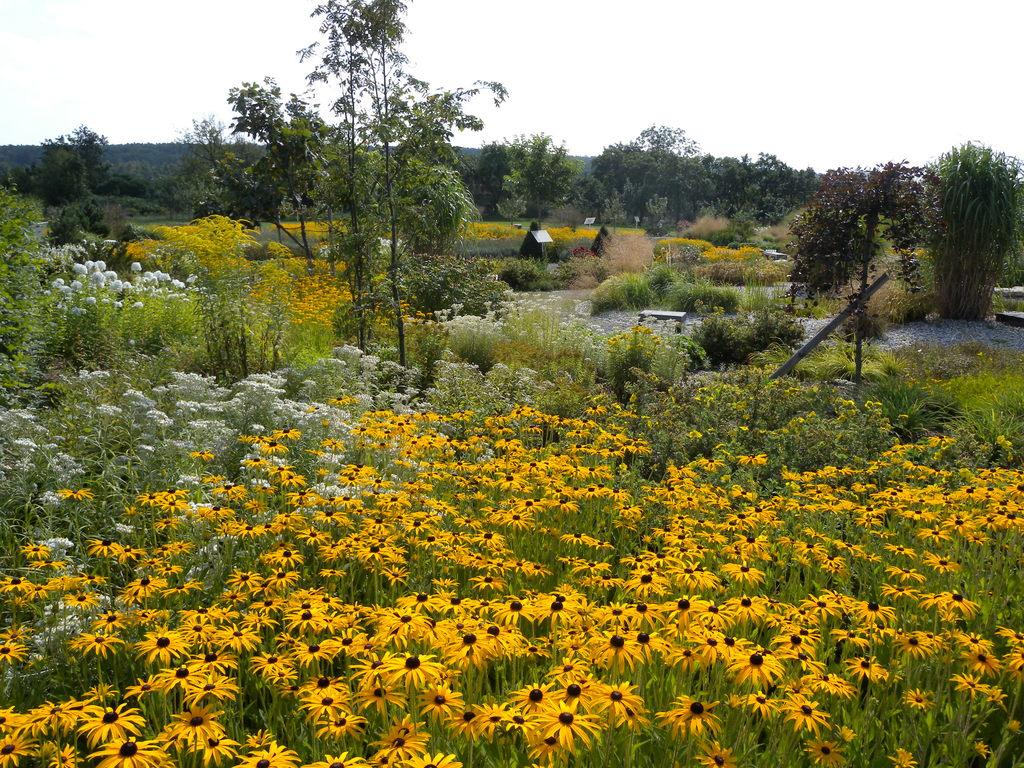What type of landscape is depicted at the bottom side of the image? There is a flower field at the bottom side of the image. What can be seen in the background area of the image? There are boards and trees in the background area of the image. What is the average income of the snails in the image? There are no snails present in the image, so it is not possible to determine their average income. 